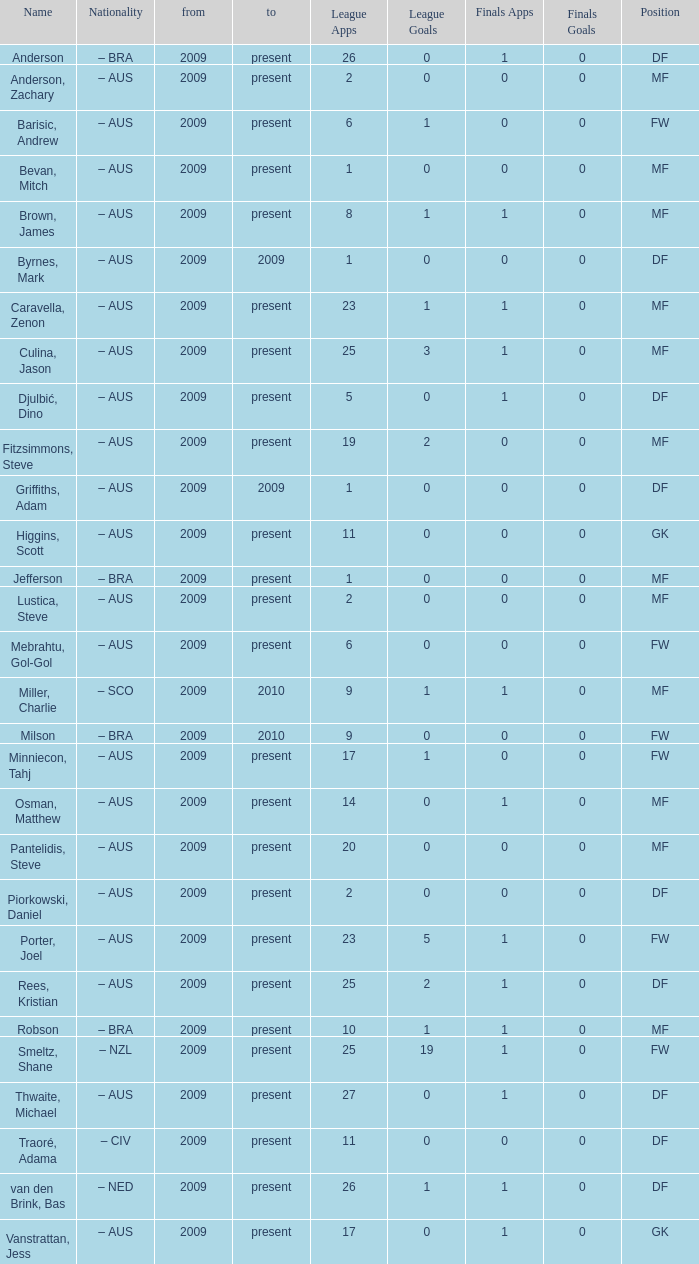Name the position for van den brink, bas DF. Could you help me parse every detail presented in this table? {'header': ['Name', 'Nationality', 'from', 'to', 'League Apps', 'League Goals', 'Finals Apps', 'Finals Goals', 'Position'], 'rows': [['Anderson', '– BRA', '2009', 'present', '26', '0', '1', '0', 'DF'], ['Anderson, Zachary', '– AUS', '2009', 'present', '2', '0', '0', '0', 'MF'], ['Barisic, Andrew', '– AUS', '2009', 'present', '6', '1', '0', '0', 'FW'], ['Bevan, Mitch', '– AUS', '2009', 'present', '1', '0', '0', '0', 'MF'], ['Brown, James', '– AUS', '2009', 'present', '8', '1', '1', '0', 'MF'], ['Byrnes, Mark', '– AUS', '2009', '2009', '1', '0', '0', '0', 'DF'], ['Caravella, Zenon', '– AUS', '2009', 'present', '23', '1', '1', '0', 'MF'], ['Culina, Jason', '– AUS', '2009', 'present', '25', '3', '1', '0', 'MF'], ['Djulbić, Dino', '– AUS', '2009', 'present', '5', '0', '1', '0', 'DF'], ['Fitzsimmons, Steve', '– AUS', '2009', 'present', '19', '2', '0', '0', 'MF'], ['Griffiths, Adam', '– AUS', '2009', '2009', '1', '0', '0', '0', 'DF'], ['Higgins, Scott', '– AUS', '2009', 'present', '11', '0', '0', '0', 'GK'], ['Jefferson', '– BRA', '2009', 'present', '1', '0', '0', '0', 'MF'], ['Lustica, Steve', '– AUS', '2009', 'present', '2', '0', '0', '0', 'MF'], ['Mebrahtu, Gol-Gol', '– AUS', '2009', 'present', '6', '0', '0', '0', 'FW'], ['Miller, Charlie', '– SCO', '2009', '2010', '9', '1', '1', '0', 'MF'], ['Milson', '– BRA', '2009', '2010', '9', '0', '0', '0', 'FW'], ['Minniecon, Tahj', '– AUS', '2009', 'present', '17', '1', '0', '0', 'FW'], ['Osman, Matthew', '– AUS', '2009', 'present', '14', '0', '1', '0', 'MF'], ['Pantelidis, Steve', '– AUS', '2009', 'present', '20', '0', '0', '0', 'MF'], ['Piorkowski, Daniel', '– AUS', '2009', 'present', '2', '0', '0', '0', 'DF'], ['Porter, Joel', '– AUS', '2009', 'present', '23', '5', '1', '0', 'FW'], ['Rees, Kristian', '– AUS', '2009', 'present', '25', '2', '1', '0', 'DF'], ['Robson', '– BRA', '2009', 'present', '10', '1', '1', '0', 'MF'], ['Smeltz, Shane', '– NZL', '2009', 'present', '25', '19', '1', '0', 'FW'], ['Thwaite, Michael', '– AUS', '2009', 'present', '27', '0', '1', '0', 'DF'], ['Traoré, Adama', '– CIV', '2009', 'present', '11', '0', '0', '0', 'DF'], ['van den Brink, Bas', '– NED', '2009', 'present', '26', '1', '1', '0', 'DF'], ['Vanstrattan, Jess', '– AUS', '2009', 'present', '17', '0', '1', '0', 'GK']]} 